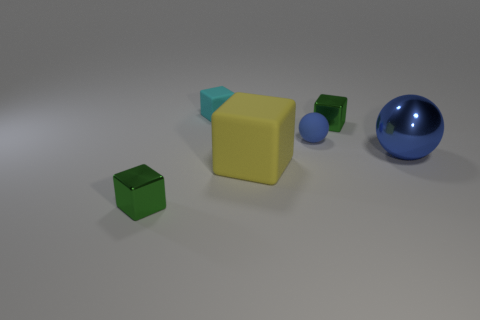What time of day do you think it is based on the lighting in the image? The lighting in the image appears neutral, likely indicative of an indoor setting with controlled, artificial lighting. There isn't enough context to deduce a specific time of day from the lighting alone. 